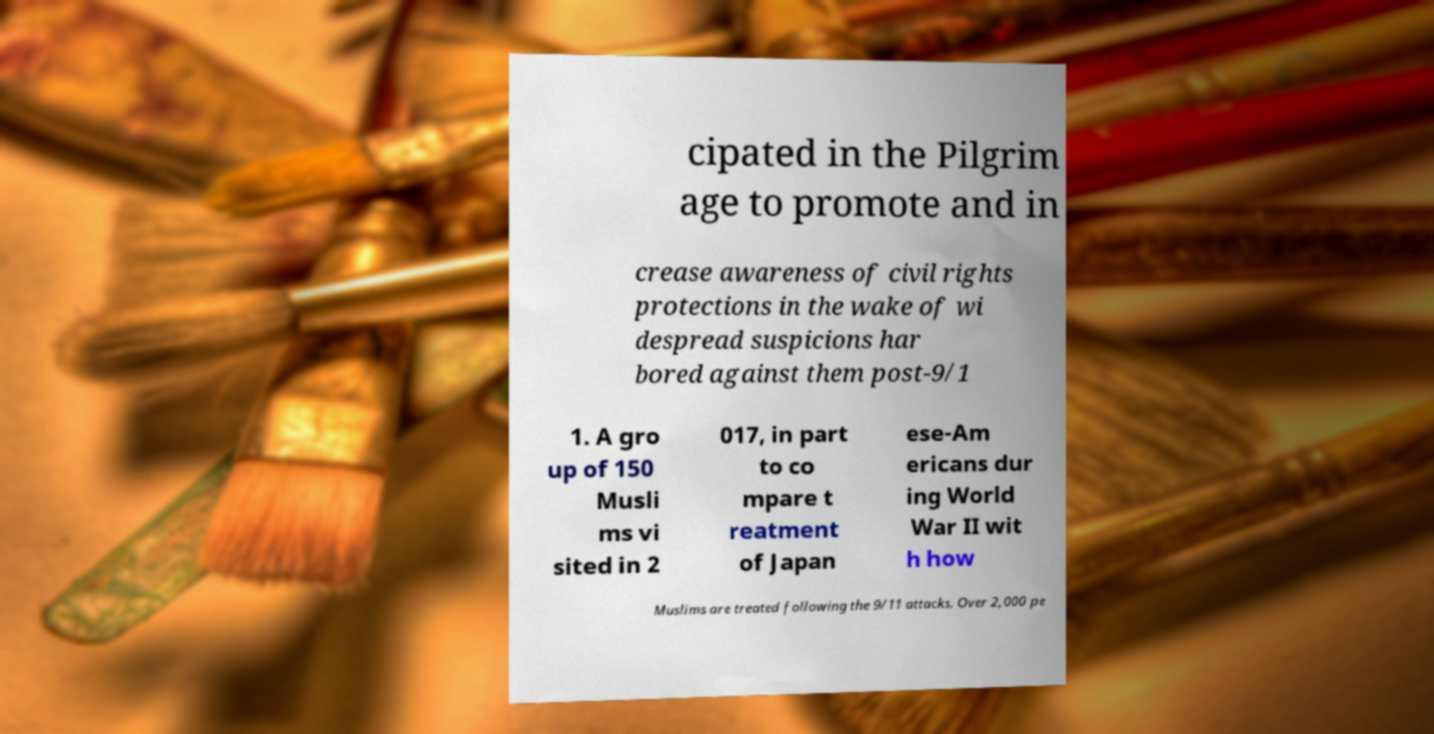Please read and relay the text visible in this image. What does it say? cipated in the Pilgrim age to promote and in crease awareness of civil rights protections in the wake of wi despread suspicions har bored against them post-9/1 1. A gro up of 150 Musli ms vi sited in 2 017, in part to co mpare t reatment of Japan ese-Am ericans dur ing World War II wit h how Muslims are treated following the 9/11 attacks. Over 2,000 pe 